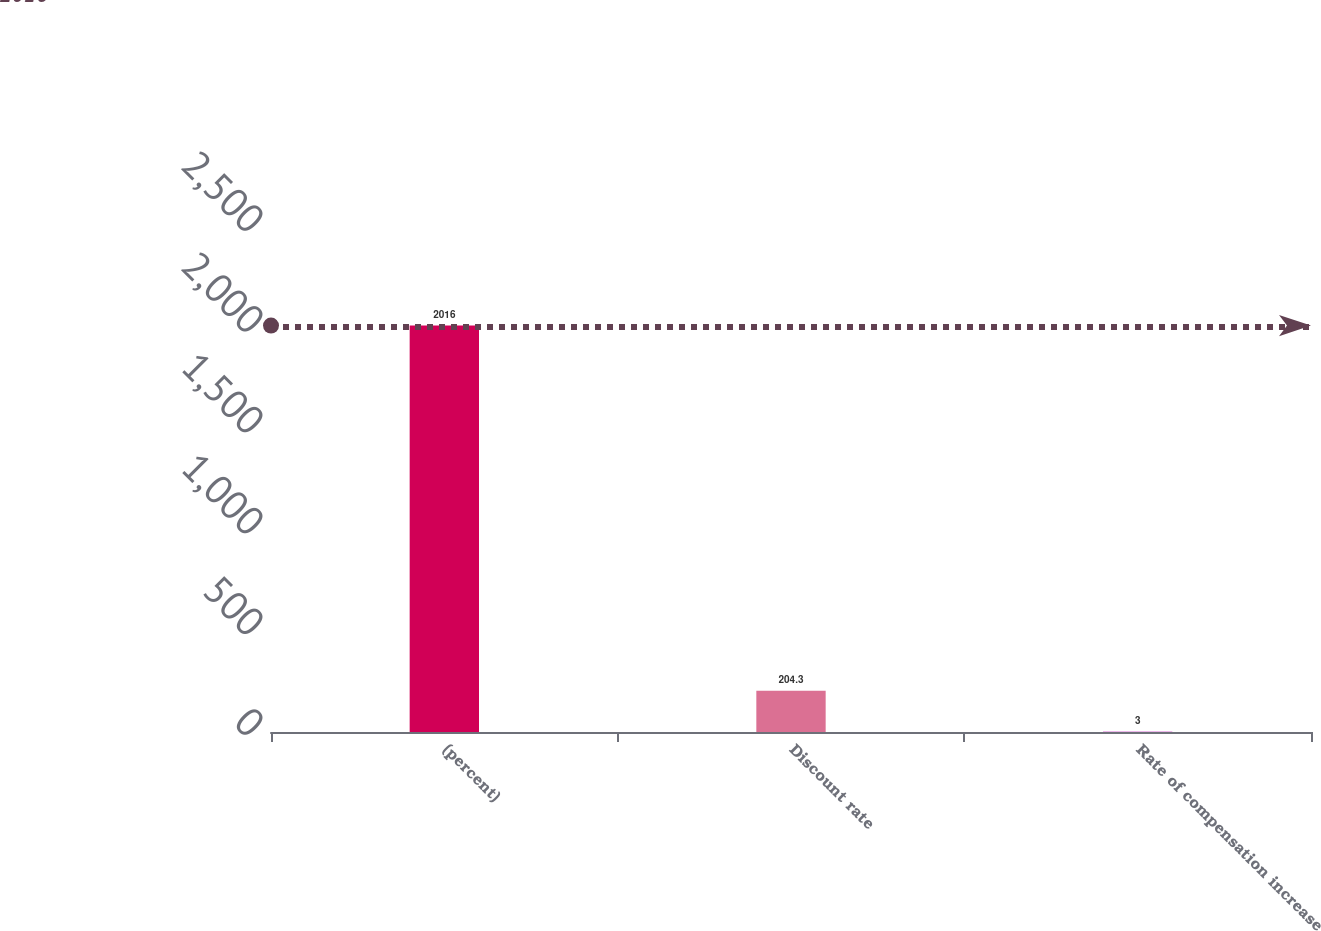Convert chart. <chart><loc_0><loc_0><loc_500><loc_500><bar_chart><fcel>(percent)<fcel>Discount rate<fcel>Rate of compensation increase<nl><fcel>2016<fcel>204.3<fcel>3<nl></chart> 